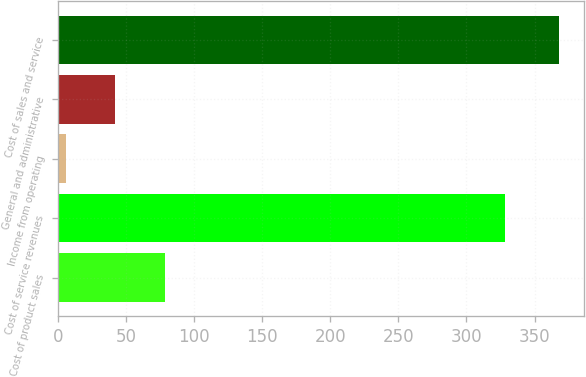Convert chart. <chart><loc_0><loc_0><loc_500><loc_500><bar_chart><fcel>Cost of product sales<fcel>Cost of service revenues<fcel>Income from operating<fcel>General and administrative<fcel>Cost of sales and service<nl><fcel>78.4<fcel>328<fcel>6<fcel>42.2<fcel>368<nl></chart> 